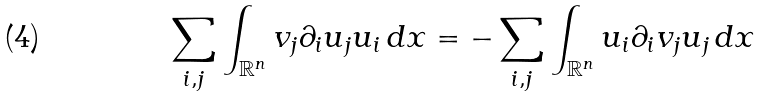Convert formula to latex. <formula><loc_0><loc_0><loc_500><loc_500>\sum _ { i , j } \int _ { \mathbb { R } ^ { n } } v _ { j } \partial _ { i } u _ { j } u _ { i } \, d x = - \sum _ { i , j } \int _ { \mathbb { R } ^ { n } } u _ { i } \partial _ { i } v _ { j } u _ { j } \, d x</formula> 